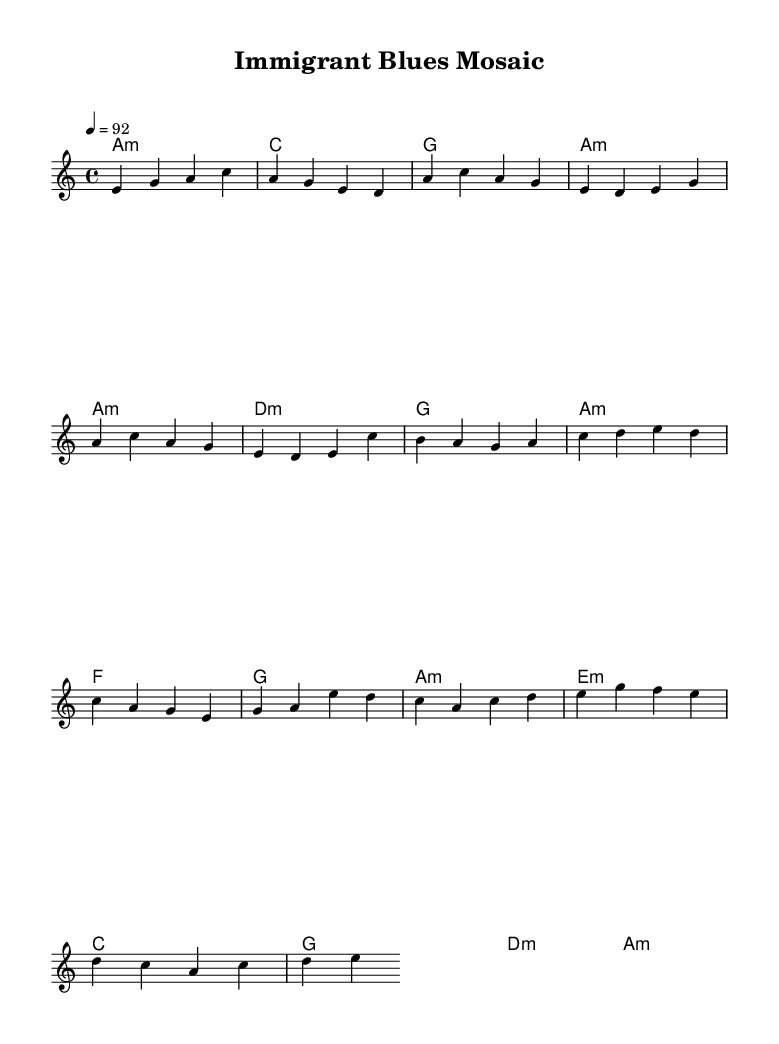What is the key signature of this music? The key signature is indicated by the note at the beginning of the staff. In this case, it shows A minor, which has no sharps or flats.
Answer: A minor What is the time signature of the piece? The time signature appears at the beginning of the music and shows four beats in a measure, specifically a four-four (4/4) time signature.
Answer: 4/4 What is the tempo marking for this piece? The tempo is specified above the staff and indicates a speed of 92 beats per minute, signified by the term 'Allegro' or similar markings.
Answer: 92 How many bars are in the intro section? By counting the number of measures separated by vertical lines in the intro section of the sheet music, there are four bars.
Answer: 4 What is the chord progression for the chorus? The chord progression for the chorus can be traced by looking at the chords directly associated with the melody during that section, which shows F, G, A minor, and E minor.
Answer: F, G, A minor, E minor Which section features a bridge? The term "Bridge" is written above the musical section, indicating that it follows the verse and is identified as the bridge section of the piece.
Answer: Bridge What type of music does this sheet music represent? The title gives a strong indication of the genre, and the structure, harmonies, and rhythm are characteristic of contemporary blues fusion, which reflects varied urban immigrant experiences.
Answer: Blues fusion 